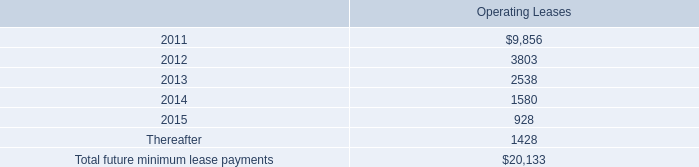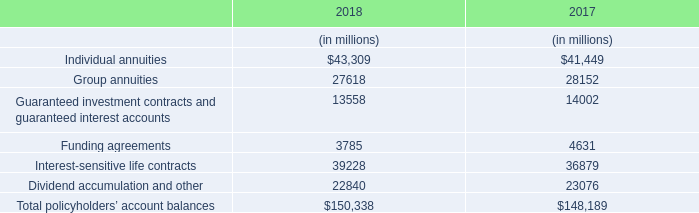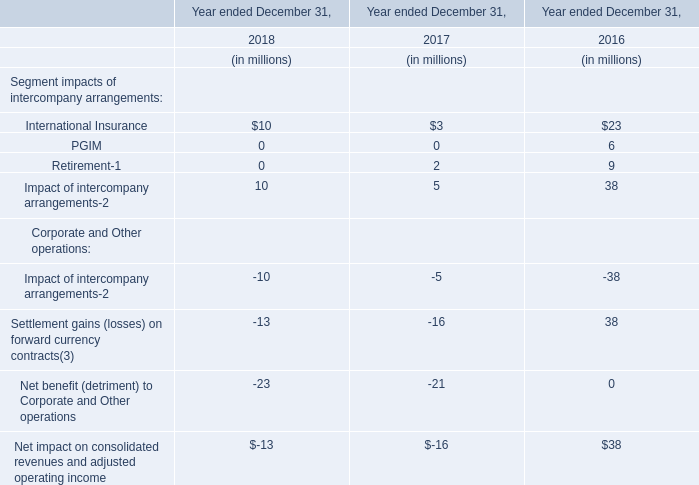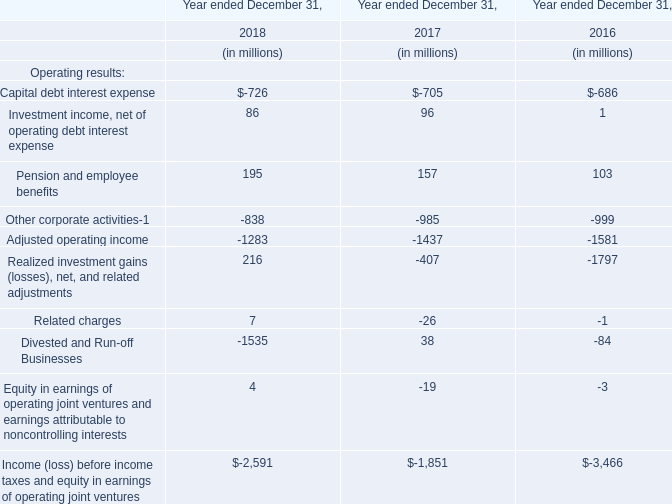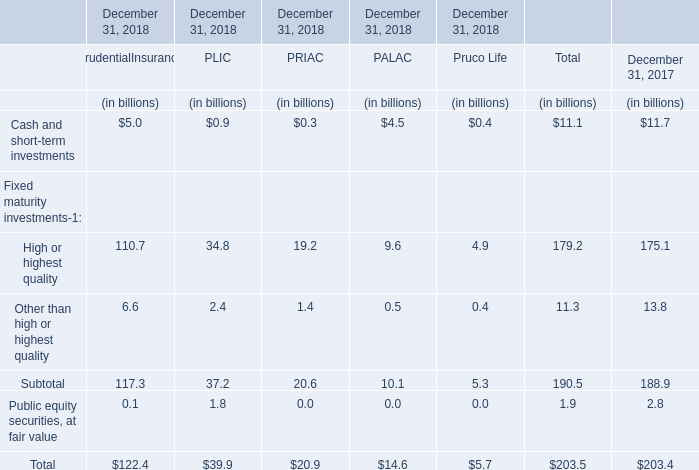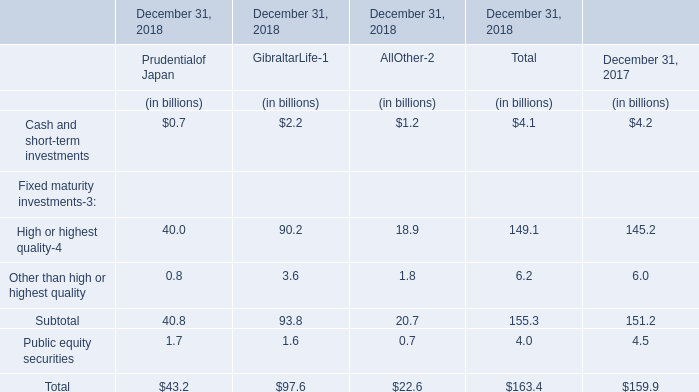What's the growth rate of the value of the total Public equity securities on December 31 in 2018? 
Computations: ((4.0 - 4.5) / 4.5)
Answer: -0.11111. 